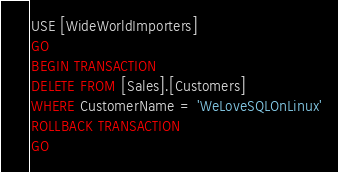Convert code to text. <code><loc_0><loc_0><loc_500><loc_500><_SQL_>USE [WideWorldImporters]
GO
BEGIN TRANSACTION
DELETE FROM [Sales].[Customers]
WHERE CustomerName = 'WeLoveSQLOnLinux'
ROLLBACK TRANSACTION
GO</code> 